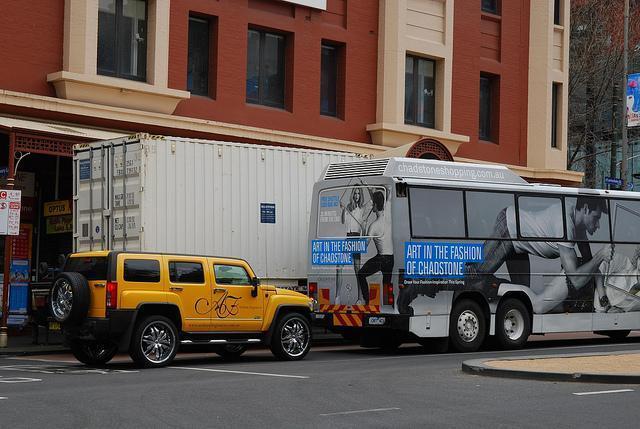How many people are in the yellow cart?
Give a very brief answer. 1. How many trucks are in the photo?
Give a very brief answer. 2. 